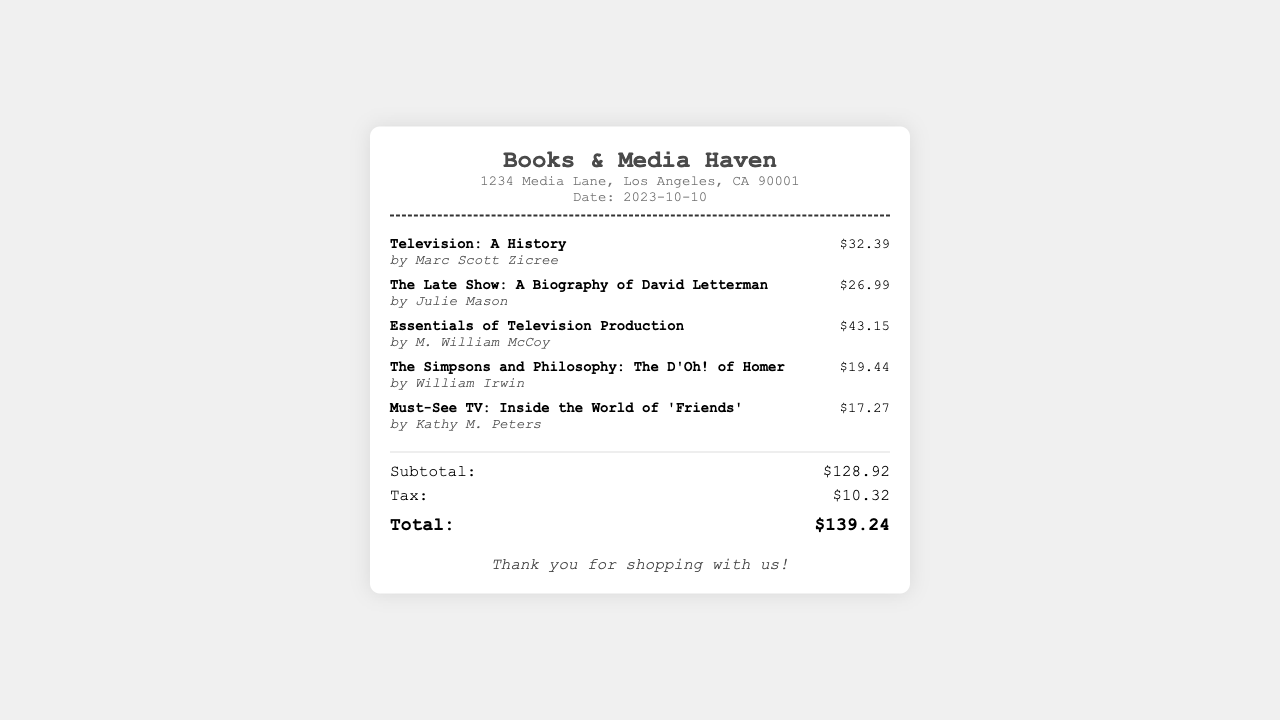What is the date of the purchase? The date of the purchase is mentioned in the document, specifically noted as "Date: 2023-10-10".
Answer: 2023-10-10 What is the name of the store? The name of the store is prominently displayed at the top of the receipt as "Books & Media Haven".
Answer: Books & Media Haven Who is the author of "Must-See TV: Inside the World of 'Friends'"? The author of the specified book can be found in the details section, listed as "by Kathy M. Peters".
Answer: Kathy M. Peters What is the subtotal amount before tax? The subtotal is the sum of all item prices provided, noted clearly as "Subtotal: $128.92".
Answer: $128.92 What is the total amount after tax? The total amount includes the subtotal and tax, indicated in the receipt as "Total: $139.24".
Answer: $139.24 How much is the tax charged? The tax amount is clearly defined in the totals section of the document as "Tax: $10.32".
Answer: $10.32 What is the price of "The Simpsons and Philosophy: The D'Oh! of Homer"? The price for this item can be found under its details as "$19.44".
Answer: $19.44 How many items were purchased in total? The total number of items is the count of item entries listed in the receipt, which shows five different items.
Answer: 5 What type of document is this? The document describes a financial transaction receipt related to the purchase of media books.
Answer: Receipt 